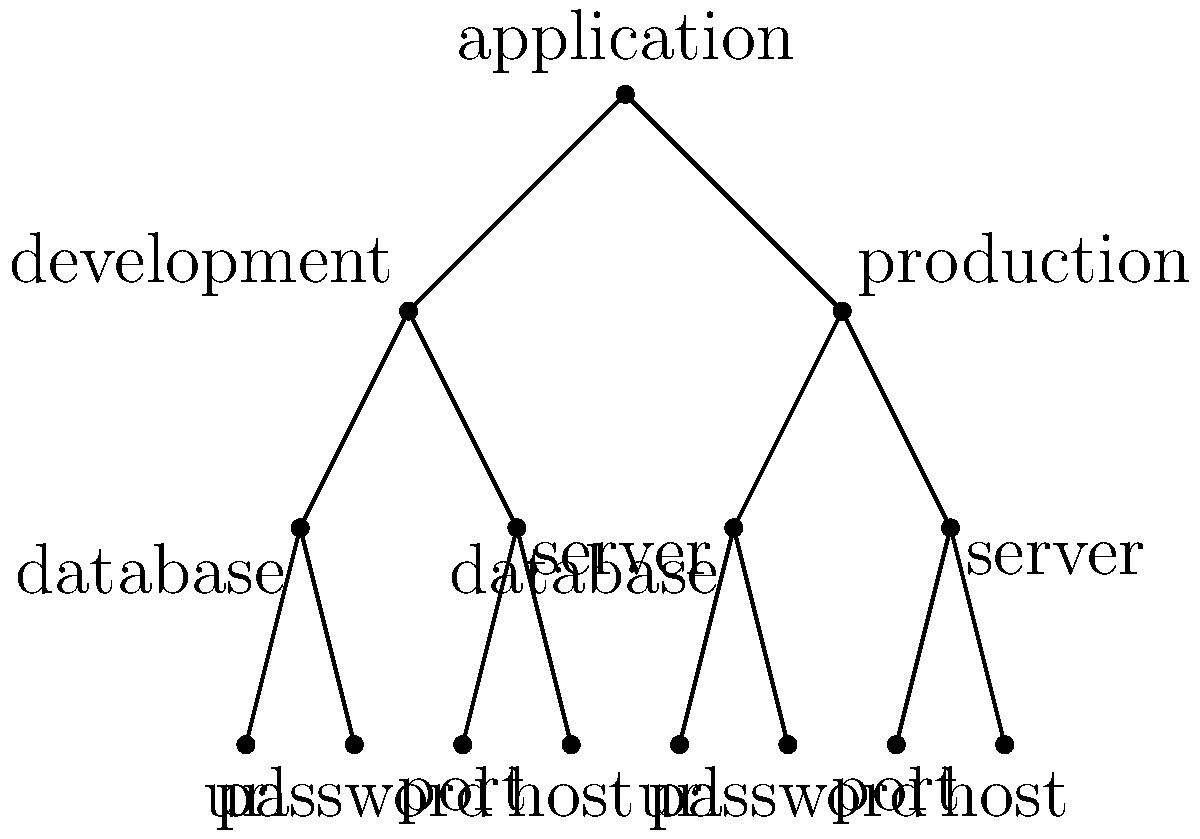In the context of Spring Cloud Config, what does the tree diagram represent, and how can it be useful when managing configuration properties for different environments? The tree diagram represents the hierarchical structure of configuration properties in Spring Cloud Config. Let's break it down step-by-step:

1. Root level: The topmost node represents the "application" level, which contains common properties for all environments.

2. Second level: This level shows two environments - "development" and "production". These represent different deployment scenarios with potentially different configuration values.

3. Third level: Under each environment, we see "database" and "server" configurations. This indicates that both development and production environments have separate database and server settings.

4. Leaf level: The bottom level shows specific properties for each configuration category, such as "url", "password", "port", and "host" for both database and server configurations.

This hierarchical structure is useful in Spring Cloud Config for several reasons:

a) Property overriding: Properties defined at lower levels can override those at higher levels, allowing for environment-specific configurations.

b) Inheritance: Common properties can be defined at the root level and inherited by all environments, reducing duplication.

c) Organization: It provides a clear structure for organizing properties, making it easier to manage and understand the configuration.

d) Separation of concerns: Different teams can manage different parts of the configuration (e.g., database team manages database properties, while the server team manages server properties).

e) Version control: When used with Git, this structure allows for easy tracking of changes and rollbacks using version control features.

f) Dynamic updates: Spring Cloud Config can reload properties at runtime, making it easier to update configurations without restarting applications.

Understanding this structure helps developers efficiently manage and organize configuration properties across different environments in a Spring Cloud Config setup.
Answer: Hierarchical configuration structure for environment-specific properties 